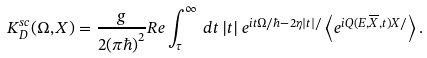<formula> <loc_0><loc_0><loc_500><loc_500>K ^ { s c } _ { D } ( \Omega , X ) = \frac { g } { 2 ( \pi \hbar { ) } ^ { 2 } } R e \int _ { \tau } ^ { \infty } \, d t \, | t | \, e ^ { i t \Omega / \hbar { - } 2 \eta | t | / } \left \langle e ^ { i Q ( E , \overline { X } , t ) X / } \right \rangle .</formula> 